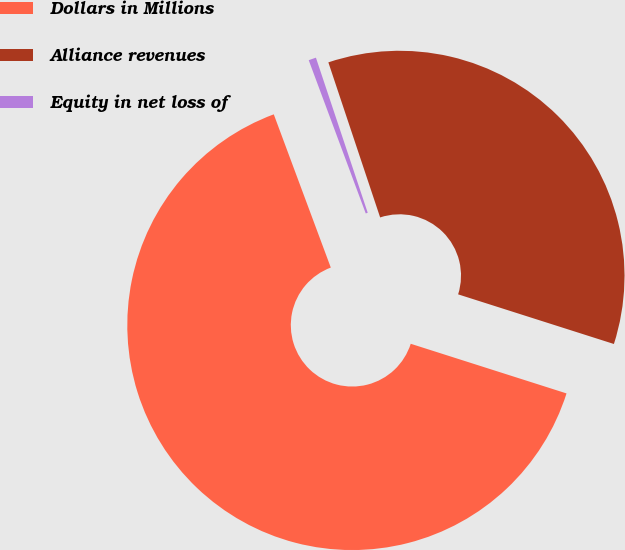Convert chart. <chart><loc_0><loc_0><loc_500><loc_500><pie_chart><fcel>Dollars in Millions<fcel>Alliance revenues<fcel>Equity in net loss of<nl><fcel>64.42%<fcel>35.04%<fcel>0.54%<nl></chart> 